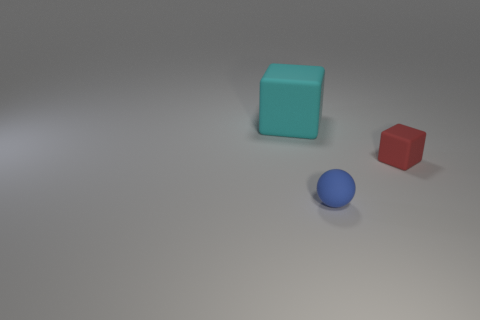Add 2 blue rubber things. How many objects exist? 5 Subtract all balls. How many objects are left? 2 Add 2 tiny matte balls. How many tiny matte balls are left? 3 Add 3 big brown balls. How many big brown balls exist? 3 Subtract 1 cyan blocks. How many objects are left? 2 Subtract all big matte cubes. Subtract all blue balls. How many objects are left? 1 